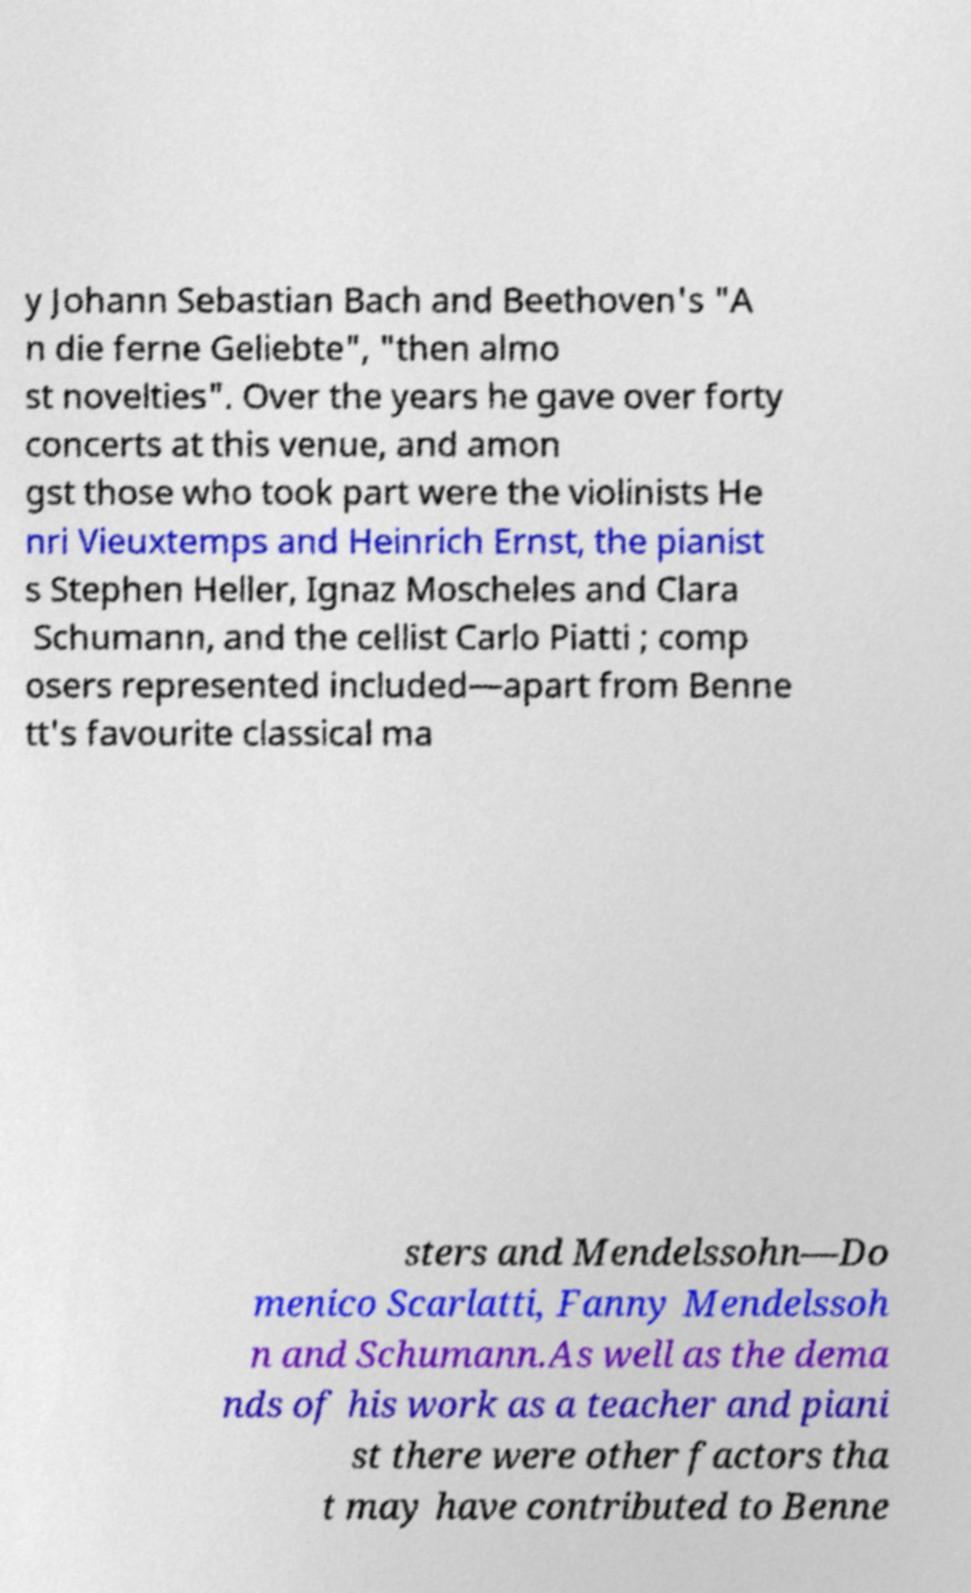Please read and relay the text visible in this image. What does it say? y Johann Sebastian Bach and Beethoven's "A n die ferne Geliebte", "then almo st novelties". Over the years he gave over forty concerts at this venue, and amon gst those who took part were the violinists He nri Vieuxtemps and Heinrich Ernst, the pianist s Stephen Heller, Ignaz Moscheles and Clara Schumann, and the cellist Carlo Piatti ; comp osers represented included—apart from Benne tt's favourite classical ma sters and Mendelssohn—Do menico Scarlatti, Fanny Mendelssoh n and Schumann.As well as the dema nds of his work as a teacher and piani st there were other factors tha t may have contributed to Benne 